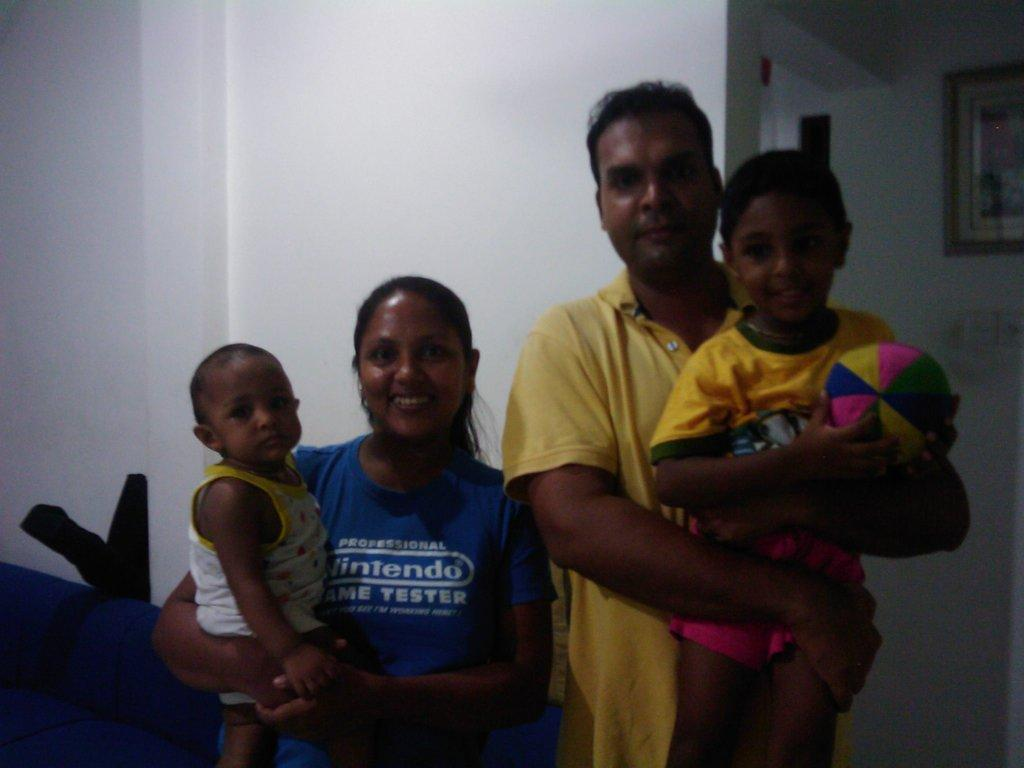Who are the main subjects in the image? There is a couple in the image. What are the couple doing in the image? The couple is holding two children. Can you describe the boy in the image? The boy is standing at the right side of the image and is holding a ball. What can be seen in the background of the image? There is a white wall in the background of the image, and there is a photo frame on the right side of the background. What type of fang can be seen in the image? There is no fang present in the image. How is the distribution of toys managed in the image? There is no mention of toys in the image, so it's not possible to determine how they are distributed. 